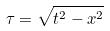Convert formula to latex. <formula><loc_0><loc_0><loc_500><loc_500>\tau = \sqrt { t ^ { 2 } - x ^ { 2 } }</formula> 